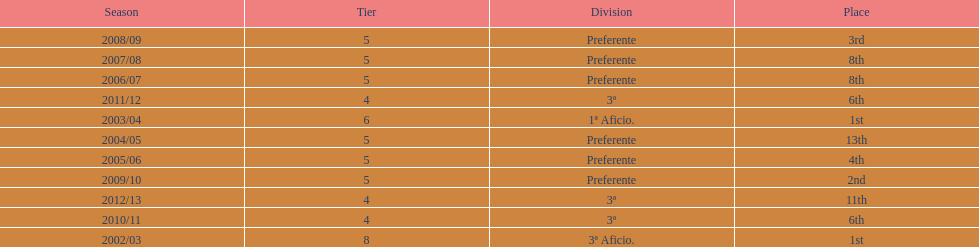Give me the full table as a dictionary. {'header': ['Season', 'Tier', 'Division', 'Place'], 'rows': [['2008/09', '5', 'Preferente', '3rd'], ['2007/08', '5', 'Preferente', '8th'], ['2006/07', '5', 'Preferente', '8th'], ['2011/12', '4', '3ª', '6th'], ['2003/04', '6', '1ª Aficio.', '1st'], ['2004/05', '5', 'Preferente', '13th'], ['2005/06', '5', 'Preferente', '4th'], ['2009/10', '5', 'Preferente', '2nd'], ['2012/13', '4', '3ª', '11th'], ['2010/11', '4', '3ª', '6th'], ['2002/03', '8', '3ª Aficio.', '1st']]} Which division placed more than aficio 1a and 3a? Preferente. 